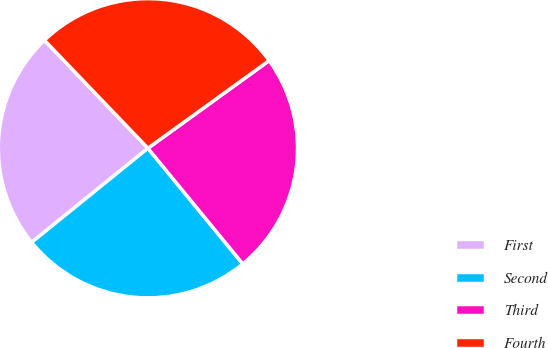Convert chart. <chart><loc_0><loc_0><loc_500><loc_500><pie_chart><fcel>First<fcel>Second<fcel>Third<fcel>Fourth<nl><fcel>23.67%<fcel>25.1%<fcel>24.03%<fcel>27.2%<nl></chart> 